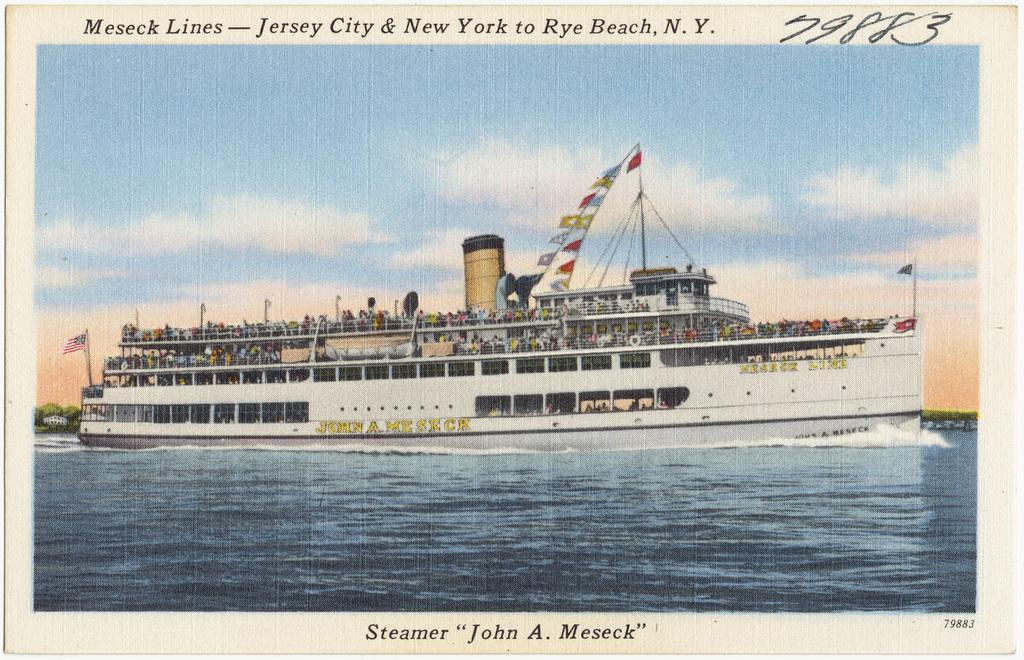Can you describe this image briefly? In this picture we can observe a ship on the water. The ship is in white color. There are some people in the ship. We can observe black color words in this picture. In the background there is a sky with clouds. 